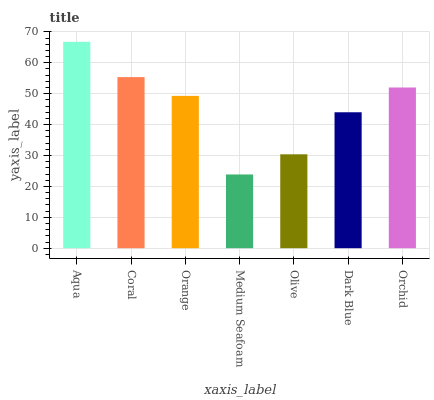Is Medium Seafoam the minimum?
Answer yes or no. Yes. Is Aqua the maximum?
Answer yes or no. Yes. Is Coral the minimum?
Answer yes or no. No. Is Coral the maximum?
Answer yes or no. No. Is Aqua greater than Coral?
Answer yes or no. Yes. Is Coral less than Aqua?
Answer yes or no. Yes. Is Coral greater than Aqua?
Answer yes or no. No. Is Aqua less than Coral?
Answer yes or no. No. Is Orange the high median?
Answer yes or no. Yes. Is Orange the low median?
Answer yes or no. Yes. Is Orchid the high median?
Answer yes or no. No. Is Medium Seafoam the low median?
Answer yes or no. No. 